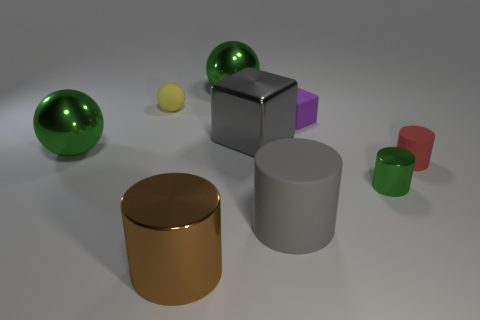Does the green metal object that is in front of the small matte cylinder have the same shape as the tiny red thing?
Provide a succinct answer. Yes. Is the number of green shiny cylinders that are in front of the big brown shiny cylinder less than the number of green metallic things to the right of the small yellow rubber object?
Provide a succinct answer. Yes. What material is the small yellow sphere?
Provide a succinct answer. Rubber. There is a tiny rubber cylinder; is its color the same as the tiny ball that is to the left of the gray shiny block?
Give a very brief answer. No. There is a tiny yellow matte object; what number of big objects are in front of it?
Provide a succinct answer. 4. Is the number of gray objects that are to the right of the red matte object less than the number of tiny green metallic balls?
Offer a terse response. No. The tiny sphere has what color?
Your answer should be compact. Yellow. There is a tiny thing in front of the tiny red thing; is it the same color as the small rubber cube?
Offer a very short reply. No. The other large matte object that is the same shape as the red rubber object is what color?
Offer a terse response. Gray. What number of tiny things are either red objects or gray cubes?
Make the answer very short. 1. 